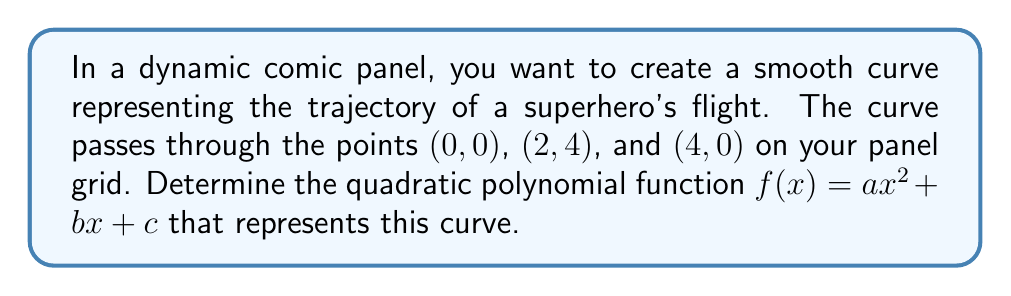What is the answer to this math problem? Let's approach this step-by-step:

1) We know the curve passes through three points: (0, 0), (2, 4), and (4, 0).

2) For a quadratic function $f(x) = ax^2 + bx + c$, we need to find the values of $a$, $b$, and $c$.

3) Let's use these points to create a system of equations:

   For (0, 0): $f(0) = a(0)^2 + b(0) + c = 0$
   For (2, 4): $f(2) = a(2)^2 + b(2) + c = 4$
   For (4, 0): $f(4) = a(4)^2 + b(4) + c = 0$

4) Simplifying:

   $c = 0$
   $4a + 2b = 4$
   $16a + 4b = 0$

5) From the first equation, we know $c = 0$. Let's solve for $a$ and $b$ using the other two:

   Multiply the second equation by 2: $8a + 4b = 8$
   Subtract this from the third equation: $8a = -8$

6) Solving:

   $a = -1$

7) Substitute this back into $4a + 2b = 4$:

   $4(-1) + 2b = 4$
   $-4 + 2b = 4$
   $2b = 8$
   $b = 4$

8) Therefore, the quadratic function is:

   $f(x) = -x^2 + 4x + 0$

   Which simplifies to:

   $f(x) = -x^2 + 4x$
Answer: $f(x) = -x^2 + 4x$ 